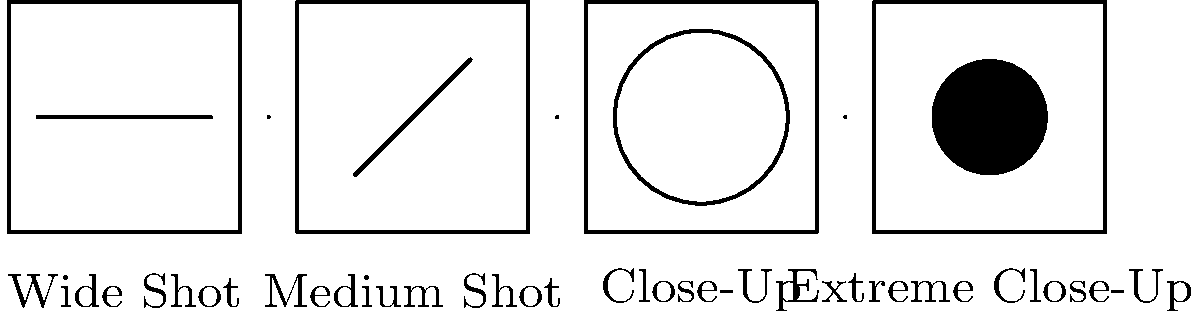As a film director, you're planning a crucial scene for your next project. Using the storyboard illustrations provided, which camera angle progression would you choose to create a sense of increasing intensity and emotional impact? To create a sense of increasing intensity and emotional impact, we need to analyze the progression of camera angles shown in the storyboard:

1. Wide Shot: This establishes the overall scene and context.
2. Medium Shot: Brings us closer to the subject, showing more detail.
3. Close-Up: Focuses on the character's face, revealing emotions.
4. Extreme Close-Up: Emphasizes specific details, creating maximum impact.

The progression from wide to extreme close-up naturally builds intensity by:

1. Starting with context (Wide Shot)
2. Narrowing the focus (Medium Shot)
3. Revealing emotions (Close-Up)
4. Emphasizing crucial details (Extreme Close-Up)

This sequence gradually draws the viewer in, increasing emotional connection and intensity with each shot. It's a classic technique used in filmmaking to build tension and impact.
Answer: Wide Shot to Extreme Close-Up 